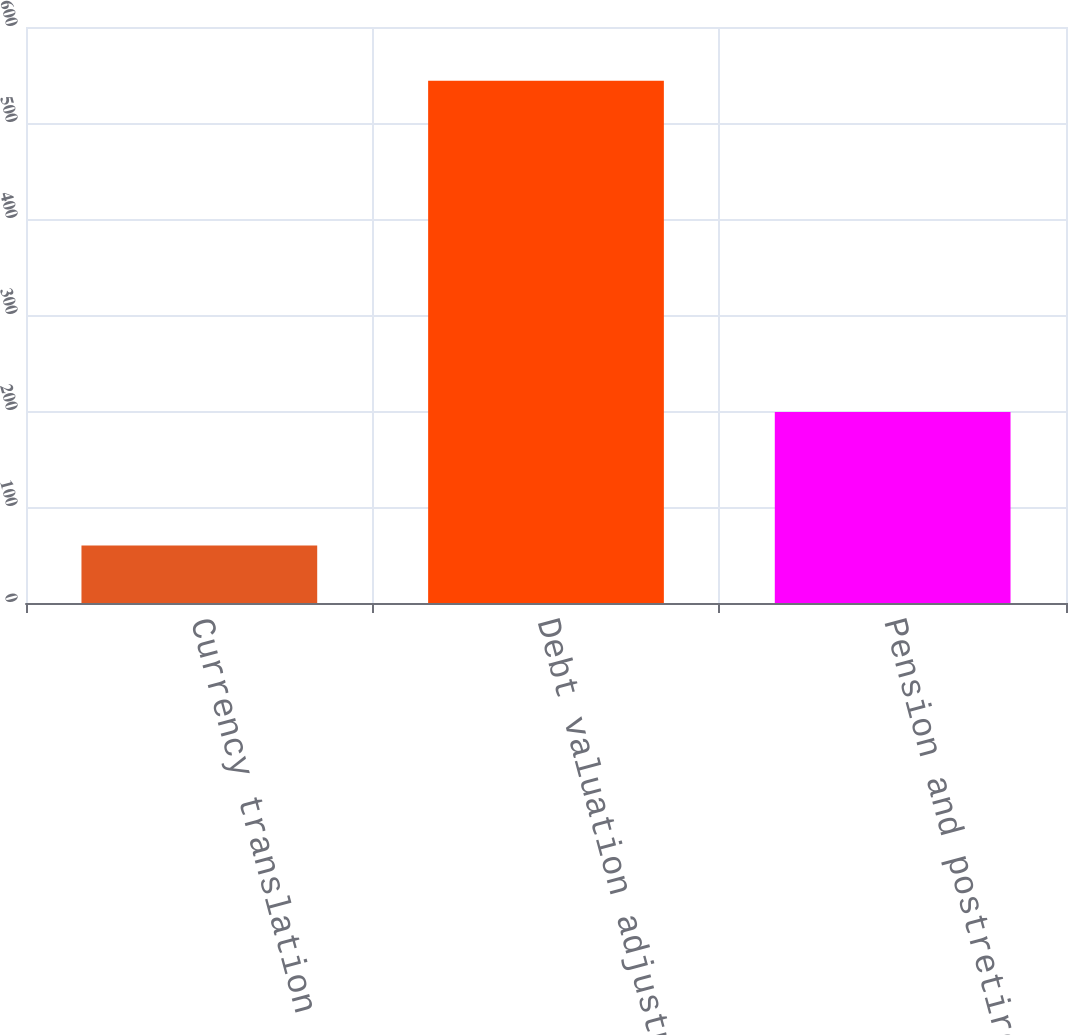Convert chart to OTSL. <chart><loc_0><loc_0><loc_500><loc_500><bar_chart><fcel>Currency translation<fcel>Debt valuation adjustment<fcel>Pension and postretirement<nl><fcel>60<fcel>544<fcel>199<nl></chart> 